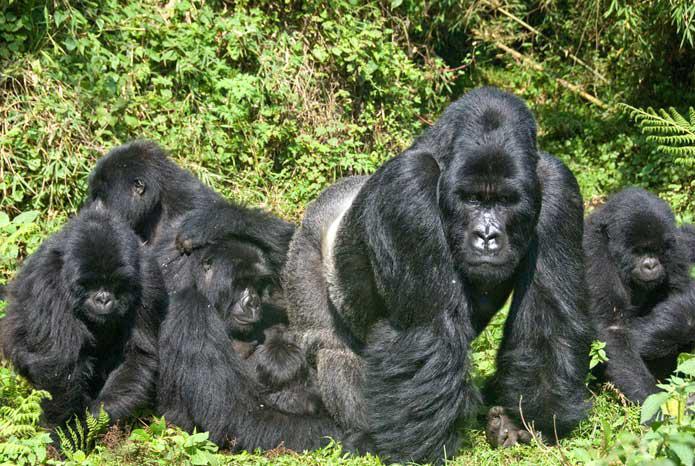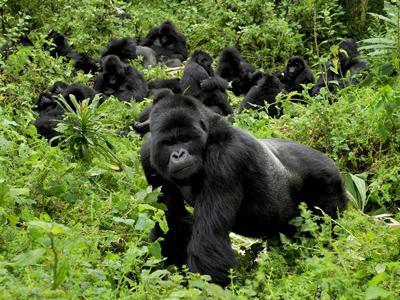The first image is the image on the left, the second image is the image on the right. For the images displayed, is the sentence "Each image contains at least five gorillas, and at least one image shows a large forward-turned male standing on all fours in the front of the group." factually correct? Answer yes or no. Yes. 